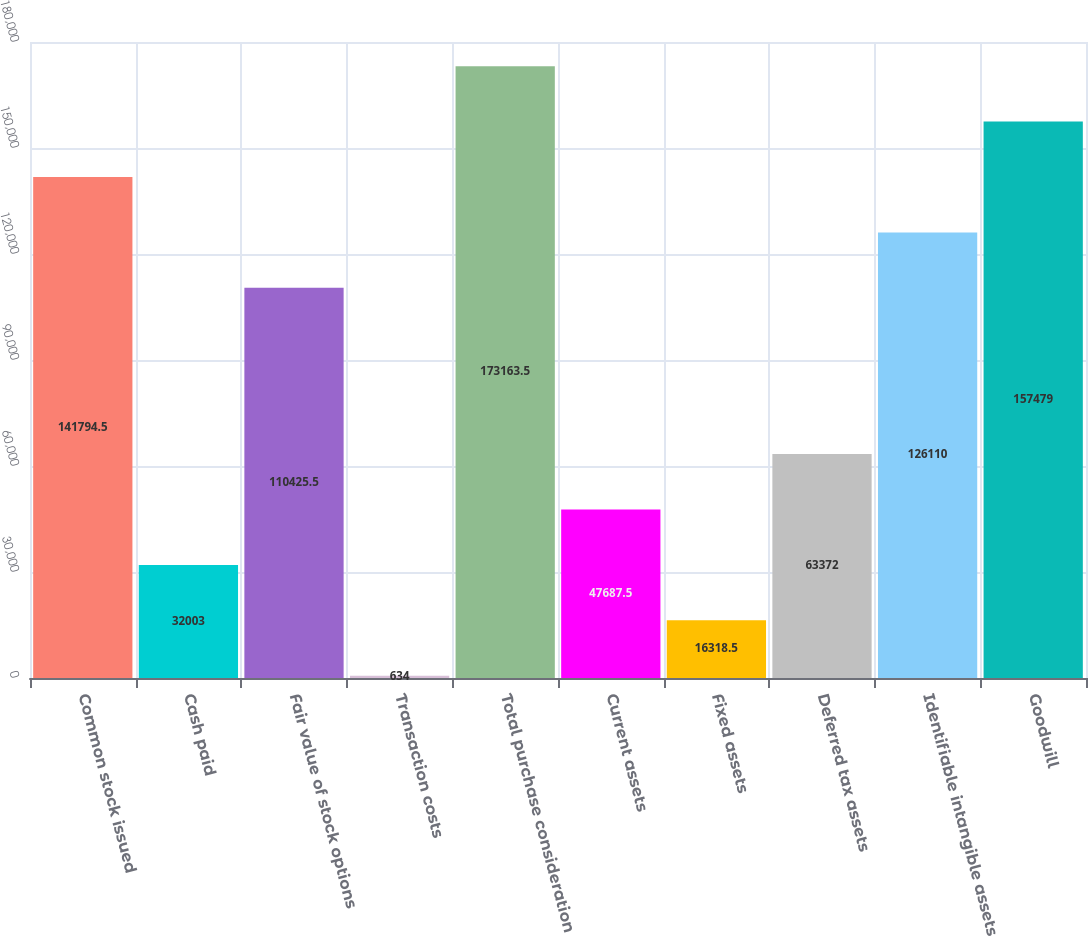<chart> <loc_0><loc_0><loc_500><loc_500><bar_chart><fcel>Common stock issued<fcel>Cash paid<fcel>Fair value of stock options<fcel>Transaction costs<fcel>Total purchase consideration<fcel>Current assets<fcel>Fixed assets<fcel>Deferred tax assets<fcel>Identifiable intangible assets<fcel>Goodwill<nl><fcel>141794<fcel>32003<fcel>110426<fcel>634<fcel>173164<fcel>47687.5<fcel>16318.5<fcel>63372<fcel>126110<fcel>157479<nl></chart> 